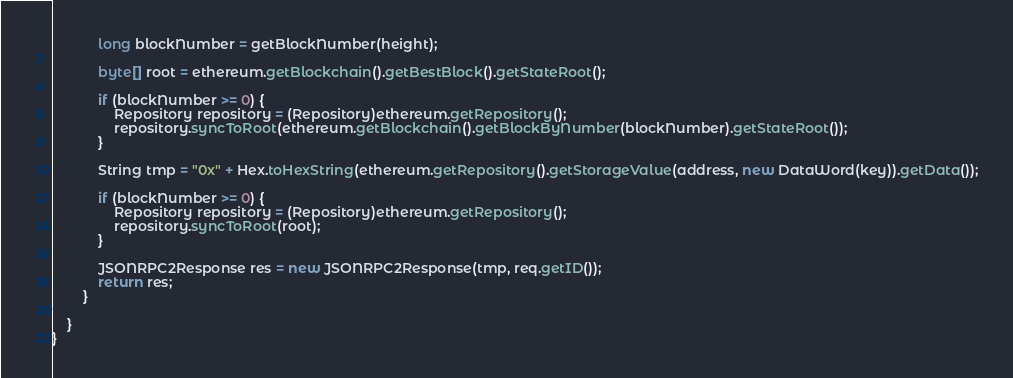<code> <loc_0><loc_0><loc_500><loc_500><_Java_>
            long blockNumber = getBlockNumber(height);

            byte[] root = ethereum.getBlockchain().getBestBlock().getStateRoot();

            if (blockNumber >= 0) {
                Repository repository = (Repository)ethereum.getRepository();
                repository.syncToRoot(ethereum.getBlockchain().getBlockByNumber(blockNumber).getStateRoot());
            }

            String tmp = "0x" + Hex.toHexString(ethereum.getRepository().getStorageValue(address, new DataWord(key)).getData());

            if (blockNumber >= 0) {
                Repository repository = (Repository)ethereum.getRepository();
                repository.syncToRoot(root);
            }

            JSONRPC2Response res = new JSONRPC2Response(tmp, req.getID());
            return res;
        }

    }
}</code> 